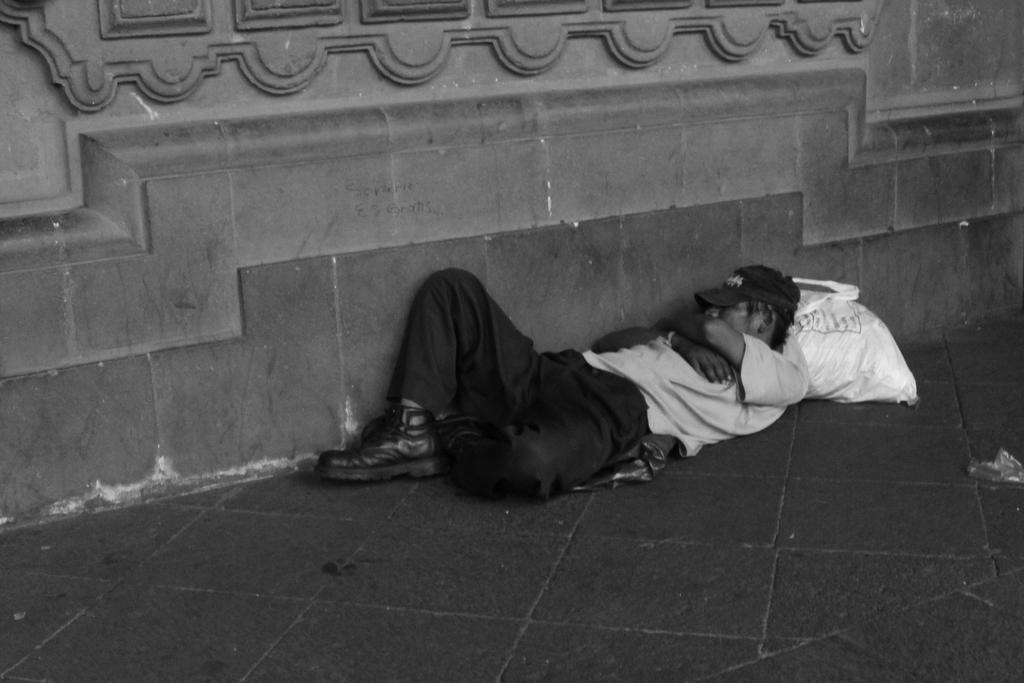What is the main subject of the image? There is a man in the image. What is the man's position in the image? The man is lying on the ground. What type of clothing is the man wearing on his head? The man is wearing a cap. What type of footwear is the man wearing? The man is wearing shoes. What type of top is the man wearing? The man is wearing a t-shirt. What type of bottoms is the man wearing? The man is wearing pants. What is the color scheme of the image? The image is black and white in color. What type of picture is the man holding in the image? There is no picture present in the image; the man is lying on the ground. Can you tell me how many cabbages are on the man's head in the image? There are no cabbages present in the image; the man is wearing a cap. 